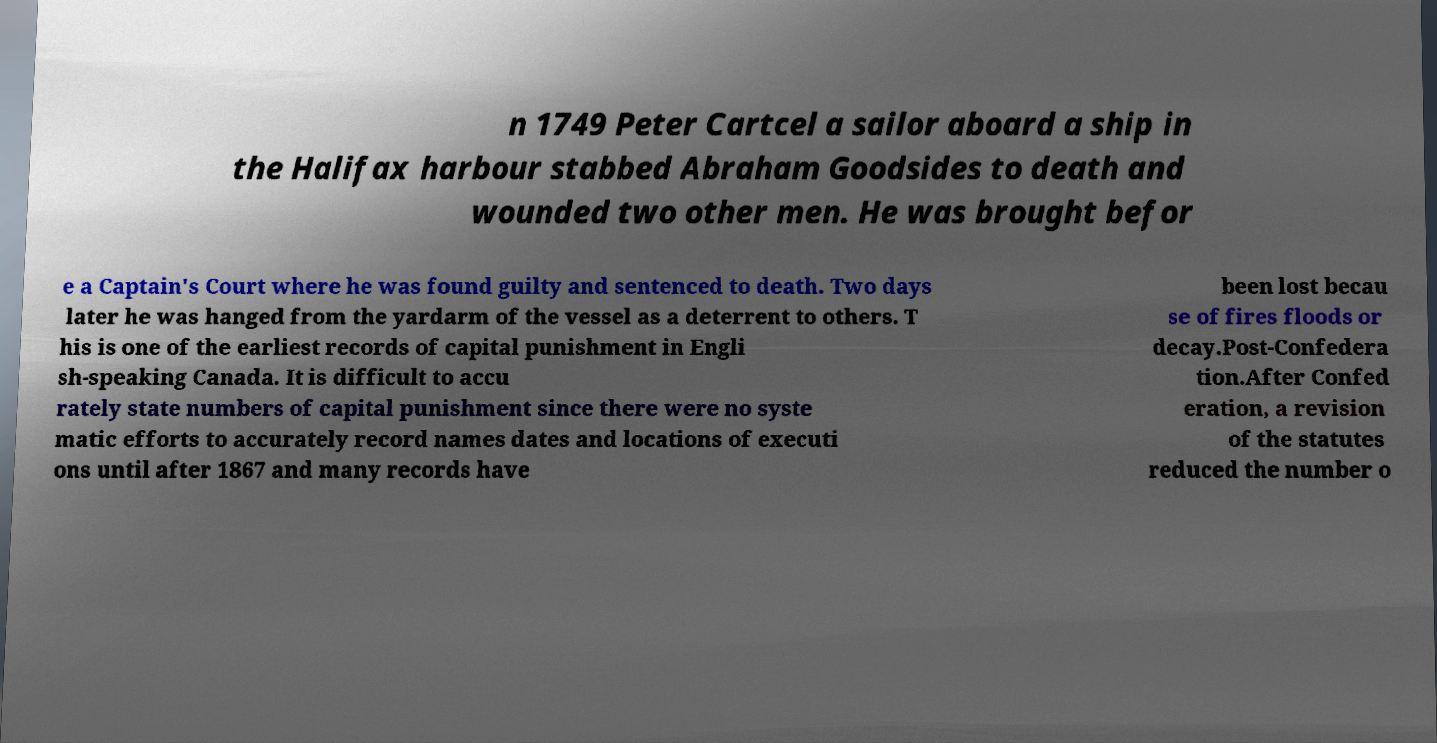Can you read and provide the text displayed in the image?This photo seems to have some interesting text. Can you extract and type it out for me? n 1749 Peter Cartcel a sailor aboard a ship in the Halifax harbour stabbed Abraham Goodsides to death and wounded two other men. He was brought befor e a Captain's Court where he was found guilty and sentenced to death. Two days later he was hanged from the yardarm of the vessel as a deterrent to others. T his is one of the earliest records of capital punishment in Engli sh-speaking Canada. It is difficult to accu rately state numbers of capital punishment since there were no syste matic efforts to accurately record names dates and locations of executi ons until after 1867 and many records have been lost becau se of fires floods or decay.Post-Confedera tion.After Confed eration, a revision of the statutes reduced the number o 